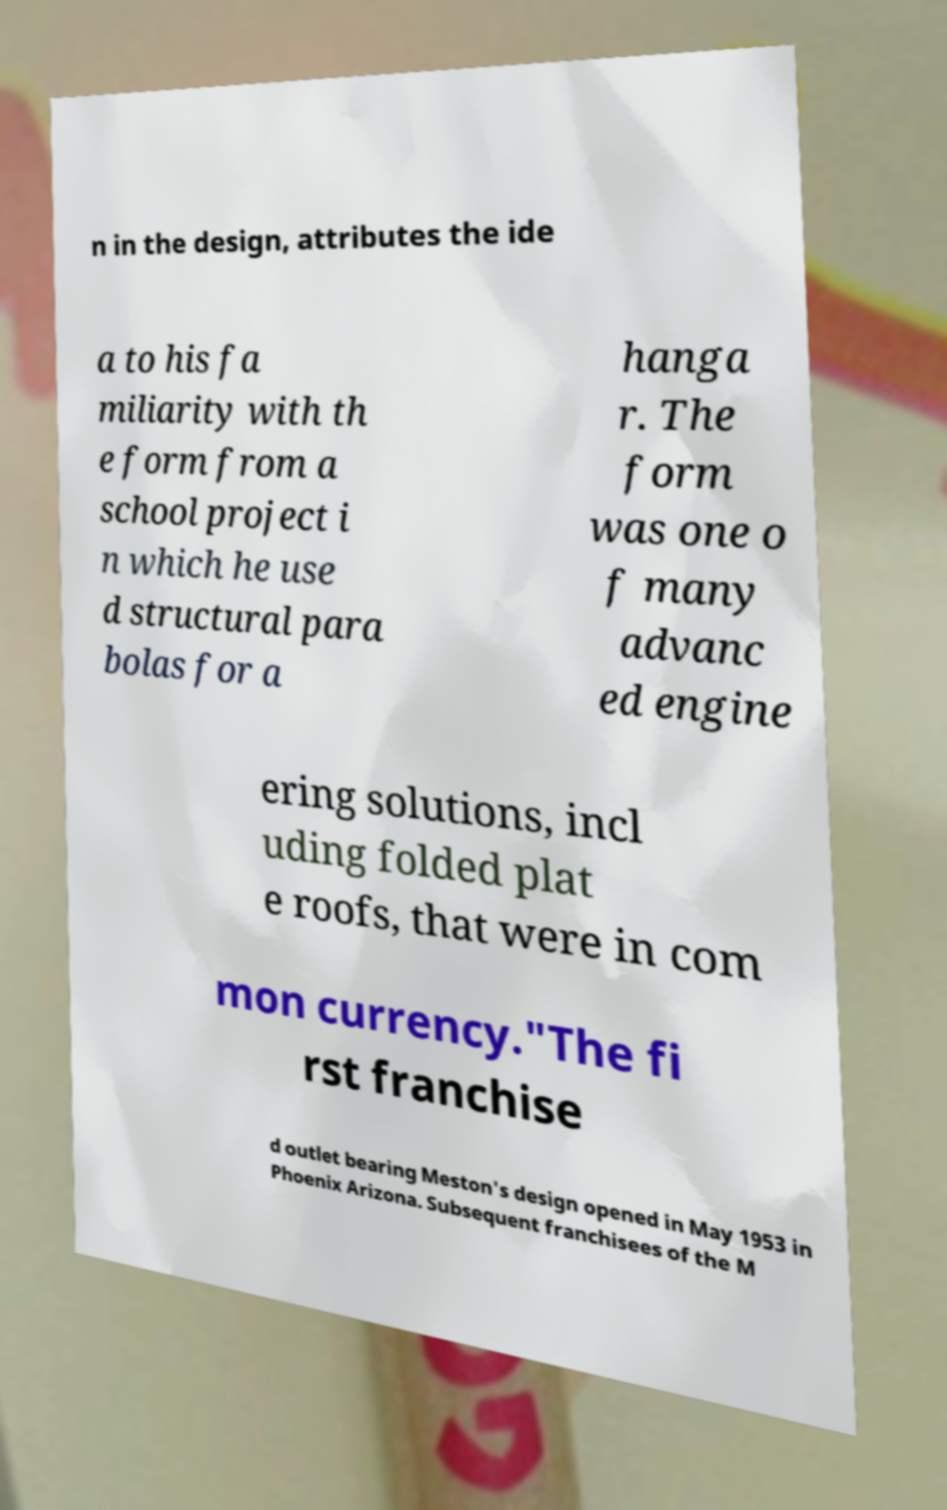Can you accurately transcribe the text from the provided image for me? n in the design, attributes the ide a to his fa miliarity with th e form from a school project i n which he use d structural para bolas for a hanga r. The form was one o f many advanc ed engine ering solutions, incl uding folded plat e roofs, that were in com mon currency."The fi rst franchise d outlet bearing Meston's design opened in May 1953 in Phoenix Arizona. Subsequent franchisees of the M 